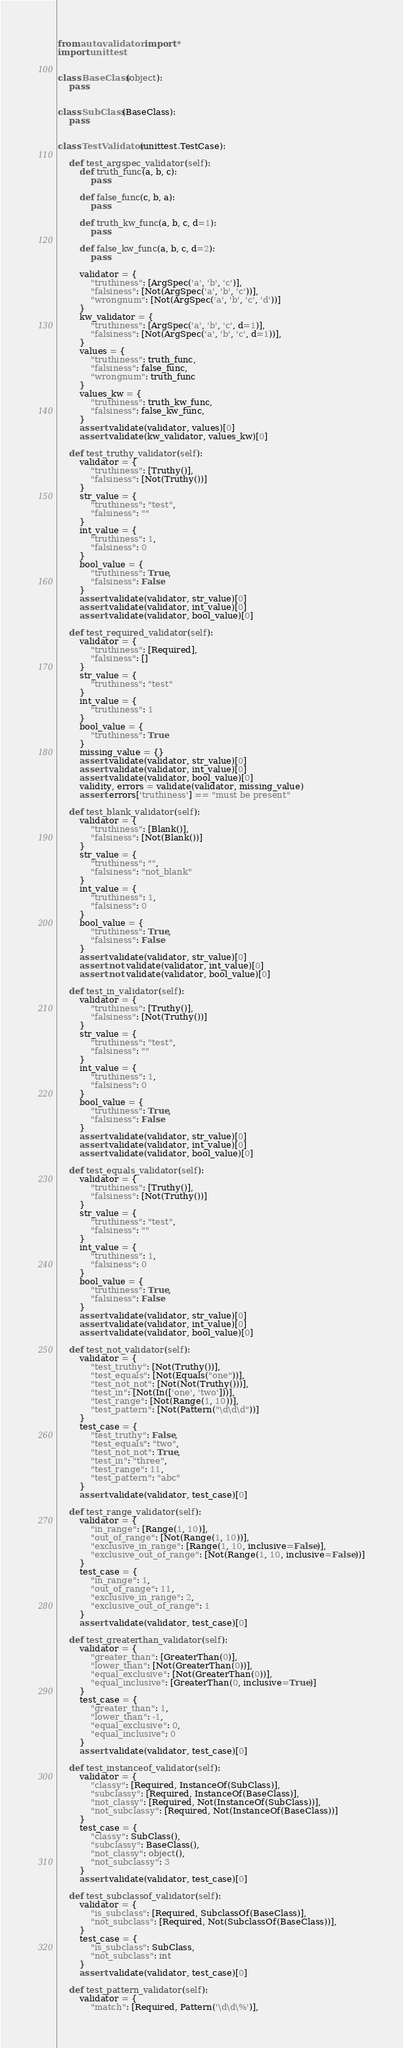Convert code to text. <code><loc_0><loc_0><loc_500><loc_500><_Python_>from auto.validator import *
import unittest


class BaseClass(object):
    pass


class SubClass(BaseClass):
    pass


class TestValidator(unittest.TestCase):

    def test_argspec_validator(self):
        def truth_func(a, b, c):
            pass

        def false_func(c, b, a):
            pass

        def truth_kw_func(a, b, c, d=1):
            pass

        def false_kw_func(a, b, c, d=2):
            pass

        validator = {
            "truthiness": [ArgSpec('a', 'b', 'c')],
            "falsiness": [Not(ArgSpec('a', 'b', 'c'))],
            "wrongnum": [Not(ArgSpec('a', 'b', 'c', 'd'))]
        }
        kw_validator = {
            "truthiness": [ArgSpec('a', 'b', 'c', d=1)],
            "falsiness": [Not(ArgSpec('a', 'b', 'c', d=1))],
        }
        values = {
            "truthiness": truth_func,
            "falsiness": false_func,
            "wrongnum": truth_func
        }
        values_kw = {
            "truthiness": truth_kw_func,
            "falsiness": false_kw_func,
        }
        assert validate(validator, values)[0]
        assert validate(kw_validator, values_kw)[0]

    def test_truthy_validator(self):
        validator = {
            "truthiness": [Truthy()],
            "falsiness": [Not(Truthy())]
        }
        str_value = {
            "truthiness": "test",
            "falsiness": ""
        }
        int_value = {
            "truthiness": 1,
            "falsiness": 0
        }
        bool_value = {
            "truthiness": True,
            "falsiness": False
        }
        assert validate(validator, str_value)[0]
        assert validate(validator, int_value)[0]
        assert validate(validator, bool_value)[0]

    def test_required_validator(self):
        validator = {
            "truthiness": [Required],
            "falsiness": []
        }
        str_value = {
            "truthiness": "test"
        }
        int_value = {
            "truthiness": 1
        }
        bool_value = {
            "truthiness": True
        }
        missing_value = {}
        assert validate(validator, str_value)[0]
        assert validate(validator, int_value)[0]
        assert validate(validator, bool_value)[0]
        validity, errors = validate(validator, missing_value)
        assert errors['truthiness'] == "must be present"

    def test_blank_validator(self):
        validator = {
            "truthiness": [Blank()],
            "falsiness": [Not(Blank())]
        }
        str_value = {
            "truthiness": "",
            "falsiness": "not_blank"
        }
        int_value = {
            "truthiness": 1,
            "falsiness": 0
        }
        bool_value = {
            "truthiness": True,
            "falsiness": False
        }
        assert validate(validator, str_value)[0]
        assert not validate(validator, int_value)[0]
        assert not validate(validator, bool_value)[0]

    def test_in_validator(self):
        validator = {
            "truthiness": [Truthy()],
            "falsiness": [Not(Truthy())]
        }
        str_value = {
            "truthiness": "test",
            "falsiness": ""
        }
        int_value = {
            "truthiness": 1,
            "falsiness": 0
        }
        bool_value = {
            "truthiness": True,
            "falsiness": False
        }
        assert validate(validator, str_value)[0]
        assert validate(validator, int_value)[0]
        assert validate(validator, bool_value)[0]

    def test_equals_validator(self):
        validator = {
            "truthiness": [Truthy()],
            "falsiness": [Not(Truthy())]
        }
        str_value = {
            "truthiness": "test",
            "falsiness": ""
        }
        int_value = {
            "truthiness": 1,
            "falsiness": 0
        }
        bool_value = {
            "truthiness": True,
            "falsiness": False
        }
        assert validate(validator, str_value)[0]
        assert validate(validator, int_value)[0]
        assert validate(validator, bool_value)[0]

    def test_not_validator(self):
        validator = {
            "test_truthy": [Not(Truthy())],
            "test_equals": [Not(Equals("one"))],
            "test_not_not": [Not(Not(Truthy()))],
            "test_in": [Not(In(['one', 'two']))],
            "test_range": [Not(Range(1, 10))],
            "test_pattern": [Not(Pattern("\d\d\d"))]
        }
        test_case = {
            "test_truthy": False,
            "test_equals": "two",
            "test_not_not": True,
            "test_in": "three",
            "test_range": 11,
            "test_pattern": "abc"
        }
        assert validate(validator, test_case)[0]

    def test_range_validator(self):
        validator = {
            "in_range": [Range(1, 10)],
            "out_of_range": [Not(Range(1, 10))],
            "exclusive_in_range": [Range(1, 10, inclusive=False)],
            "exclusive_out_of_range": [Not(Range(1, 10, inclusive=False))]
        }
        test_case = {
            "in_range": 1,
            "out_of_range": 11,
            "exclusive_in_range": 2,
            "exclusive_out_of_range": 1
        }
        assert validate(validator, test_case)[0]

    def test_greaterthan_validator(self):
        validator = {
            "greater_than": [GreaterThan(0)],
            "lower_than": [Not(GreaterThan(0))],
            "equal_exclusive": [Not(GreaterThan(0))],
            "equal_inclusive": [GreaterThan(0, inclusive=True)]
        }
        test_case = {
            "greater_than": 1,
            "lower_than": -1,
            "equal_exclusive": 0,
            "equal_inclusive": 0
        }
        assert validate(validator, test_case)[0]

    def test_instanceof_validator(self):
        validator = {
            "classy": [Required, InstanceOf(SubClass)],
            "subclassy": [Required, InstanceOf(BaseClass)],
            "not_classy": [Required, Not(InstanceOf(SubClass))],
            "not_subclassy": [Required, Not(InstanceOf(BaseClass))]
        }
        test_case = {
            "classy": SubClass(),
            "subclassy": BaseClass(),
            "not_classy": object(),
            "not_subclassy": 3
        }
        assert validate(validator, test_case)[0]

    def test_subclassof_validator(self):
        validator = {
            "is_subclass": [Required, SubclassOf(BaseClass)],
            "not_subclass": [Required, Not(SubclassOf(BaseClass))],
        }
        test_case = {
            "is_subclass": SubClass,
            "not_subclass": int
        }
        assert validate(validator, test_case)[0]

    def test_pattern_validator(self):
        validator = {
            "match": [Required, Pattern('\d\d\%')],</code> 